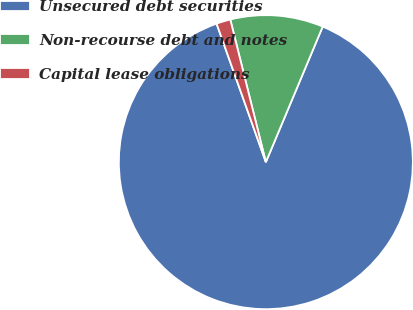<chart> <loc_0><loc_0><loc_500><loc_500><pie_chart><fcel>Unsecured debt securities<fcel>Non-recourse debt and notes<fcel>Capital lease obligations<nl><fcel>88.24%<fcel>10.21%<fcel>1.55%<nl></chart> 